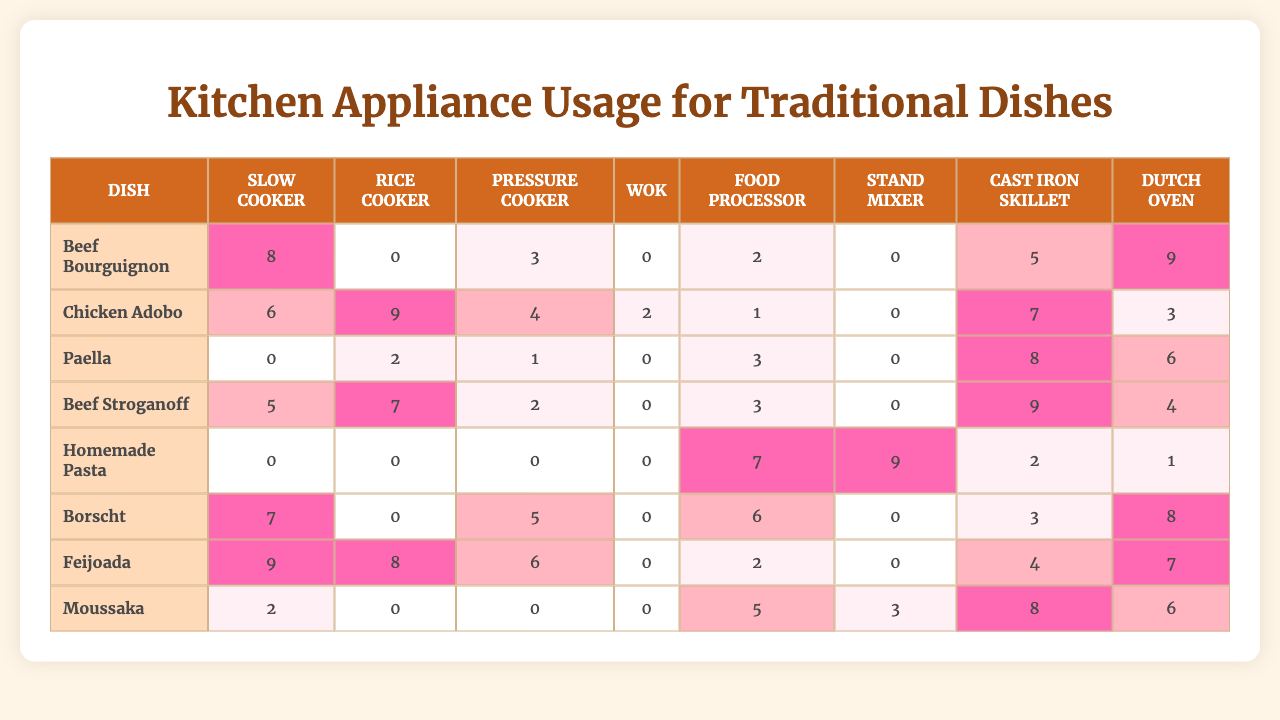What is the frequency of using a Slow Cooker for Beef Stroganoff? In the table, under "Beef Stroganoff", the frequency for the Slow Cooker is listed as 5.
Answer: 5 How often is the Food Processor used for preparing Moussaka? The table shows that the usage frequency of the Food Processor for Moussaka is 5.
Answer: 5 Which traditional dish has the highest usage frequency for the Dutch Oven? By examining the table, Beef Bourguignon has the highest usage frequency of 9 for the Dutch Oven.
Answer: Beef Bourguignon What is the total frequency of the Rice Cooker across all dishes? Summing the frequencies for the Rice Cooker: 0 (Beef Bourguignon) + 9 (Chicken Adobo) + 2 (Paella) + 7 (Beef Stroganoff) + 0 (Homemade Pasta) + 0 (Borscht) + 8 (Feijoada) + 0 (Moussaka) results in a total of 26.
Answer: 26 True or False: The Wok is never used for Beef Bourguignon. The table states that the frequency for the Wok is 0 under Beef Bourguignon, making the statement true.
Answer: True What is the average usage frequency of the Pressure Cooker for all dishes? Adding the Pressure Cooker frequencies: 3 (Beef Bourguignon) + 4 (Chicken Adobo) + 1 (Paella) + 2 (Beef Stroganoff) + 0 (Homemade Pasta) + 5 (Borscht) + 6 (Feijoada) + 0 (Moussaka) gives a sum of 21, and there are 8 dishes, so the average is 21/8 = 2.625.
Answer: 2.625 Which appliance is used the least for preparing Homemade Pasta? The table shows that the Slow Cooker, Rice Cooker, Pressure Cooker, and Wok are all used 0 times for Homemade Pasta.
Answer: Slow Cooker, Rice Cooker, Pressure Cooker, Wok If you wanted to cook Feijoada and could only use one appliance, which one would have the highest usage frequency? Under Feijoada, the Slow Cooker shows the highest usage frequency at 9, compared to other appliances.
Answer: Slow Cooker What is the difference in usage frequency for the Cast Iron Skillet between Beef Stroganoff and Borscht? The frequency for Beef Stroganoff using Cast Iron Skillet is 9, while for Borscht it is 3. The difference is 9 - 3 = 6.
Answer: 6 Which traditional dish has the highest overall usage frequency when all appliances are considered? First, we sum the usage for each dish: Beef Bourguignon = 27, Chicken Adobo = 30, Paella = 20, Beef Stroganoff = 30, Homemade Pasta = 19, Borscht = 29, Feijoada = 38, Moussaka = 24. The highest is Feijoada with 38.
Answer: Feijoada 